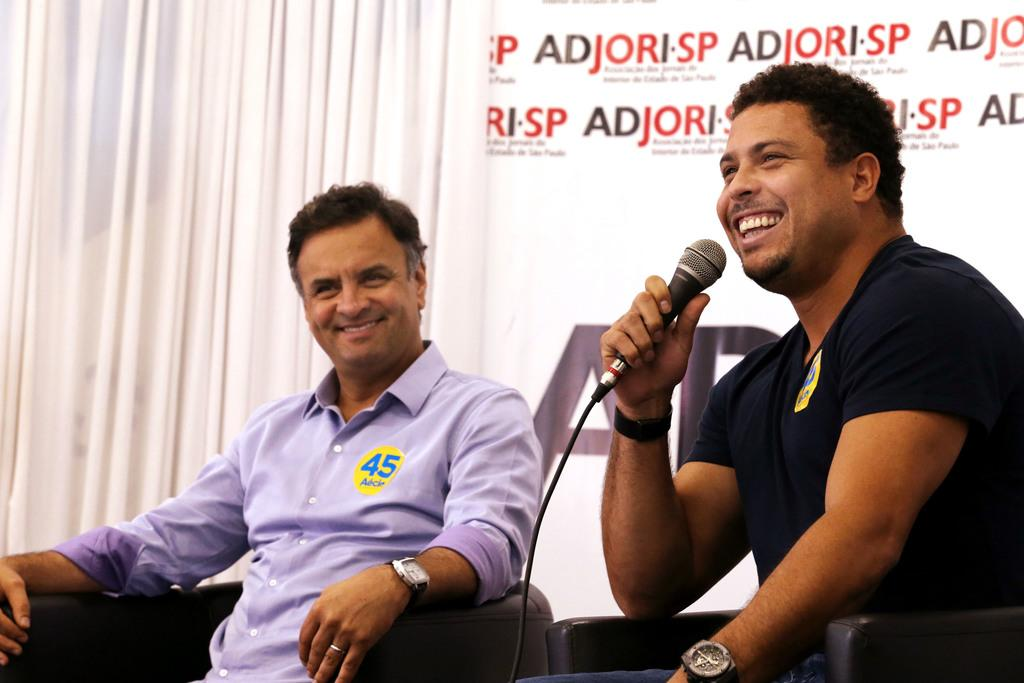How many people are in the image? There are two men in the image. What are the men doing in the image? The men are sitting on chairs. Can you describe the man holding an object in his hand? Yes, there is a man holding a microphone in his hand. What type of sticks are the men using to draw shapes in the image? There are no sticks or shapes present in the image; the men are simply sitting on chairs. 